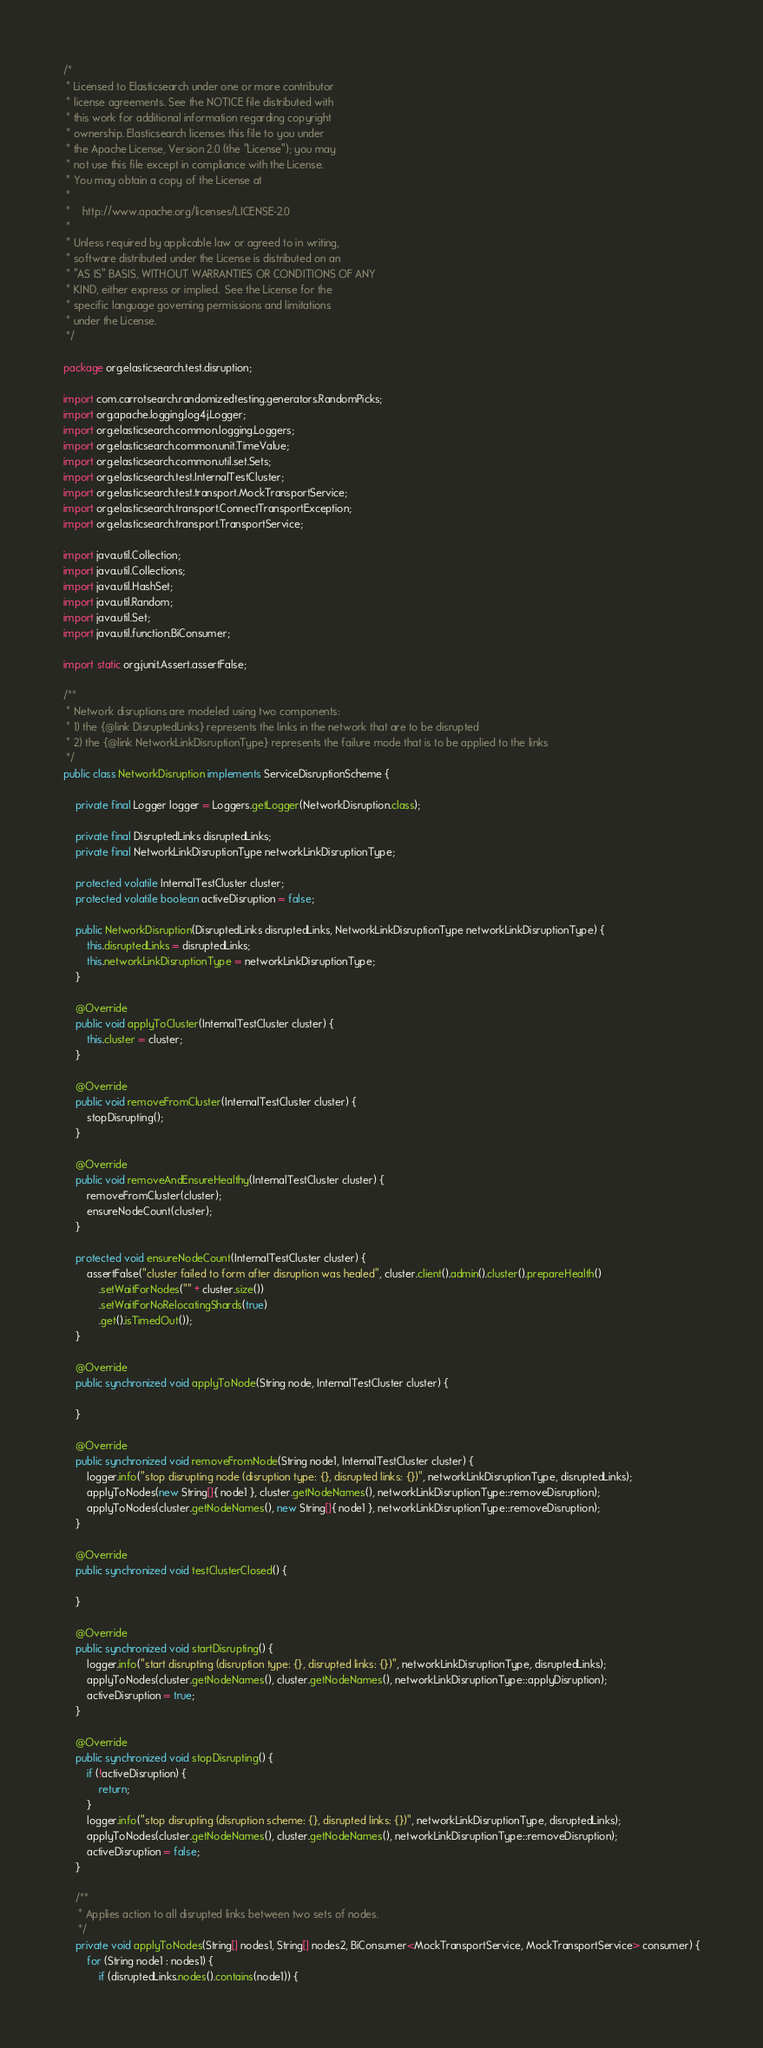<code> <loc_0><loc_0><loc_500><loc_500><_Java_>/*
 * Licensed to Elasticsearch under one or more contributor
 * license agreements. See the NOTICE file distributed with
 * this work for additional information regarding copyright
 * ownership. Elasticsearch licenses this file to you under
 * the Apache License, Version 2.0 (the "License"); you may
 * not use this file except in compliance with the License.
 * You may obtain a copy of the License at
 *
 *    http://www.apache.org/licenses/LICENSE-2.0
 *
 * Unless required by applicable law or agreed to in writing,
 * software distributed under the License is distributed on an
 * "AS IS" BASIS, WITHOUT WARRANTIES OR CONDITIONS OF ANY
 * KIND, either express or implied.  See the License for the
 * specific language governing permissions and limitations
 * under the License.
 */

package org.elasticsearch.test.disruption;

import com.carrotsearch.randomizedtesting.generators.RandomPicks;
import org.apache.logging.log4j.Logger;
import org.elasticsearch.common.logging.Loggers;
import org.elasticsearch.common.unit.TimeValue;
import org.elasticsearch.common.util.set.Sets;
import org.elasticsearch.test.InternalTestCluster;
import org.elasticsearch.test.transport.MockTransportService;
import org.elasticsearch.transport.ConnectTransportException;
import org.elasticsearch.transport.TransportService;

import java.util.Collection;
import java.util.Collections;
import java.util.HashSet;
import java.util.Random;
import java.util.Set;
import java.util.function.BiConsumer;

import static org.junit.Assert.assertFalse;

/**
 * Network disruptions are modeled using two components:
 * 1) the {@link DisruptedLinks} represents the links in the network that are to be disrupted
 * 2) the {@link NetworkLinkDisruptionType} represents the failure mode that is to be applied to the links
 */
public class NetworkDisruption implements ServiceDisruptionScheme {

    private final Logger logger = Loggers.getLogger(NetworkDisruption.class);

    private final DisruptedLinks disruptedLinks;
    private final NetworkLinkDisruptionType networkLinkDisruptionType;

    protected volatile InternalTestCluster cluster;
    protected volatile boolean activeDisruption = false;

    public NetworkDisruption(DisruptedLinks disruptedLinks, NetworkLinkDisruptionType networkLinkDisruptionType) {
        this.disruptedLinks = disruptedLinks;
        this.networkLinkDisruptionType = networkLinkDisruptionType;
    }

    @Override
    public void applyToCluster(InternalTestCluster cluster) {
        this.cluster = cluster;
    }

    @Override
    public void removeFromCluster(InternalTestCluster cluster) {
        stopDisrupting();
    }

    @Override
    public void removeAndEnsureHealthy(InternalTestCluster cluster) {
        removeFromCluster(cluster);
        ensureNodeCount(cluster);
    }

    protected void ensureNodeCount(InternalTestCluster cluster) {
        assertFalse("cluster failed to form after disruption was healed", cluster.client().admin().cluster().prepareHealth()
            .setWaitForNodes("" + cluster.size())
            .setWaitForNoRelocatingShards(true)
            .get().isTimedOut());
    }

    @Override
    public synchronized void applyToNode(String node, InternalTestCluster cluster) {

    }

    @Override
    public synchronized void removeFromNode(String node1, InternalTestCluster cluster) {
        logger.info("stop disrupting node (disruption type: {}, disrupted links: {})", networkLinkDisruptionType, disruptedLinks);
        applyToNodes(new String[]{ node1 }, cluster.getNodeNames(), networkLinkDisruptionType::removeDisruption);
        applyToNodes(cluster.getNodeNames(), new String[]{ node1 }, networkLinkDisruptionType::removeDisruption);
    }

    @Override
    public synchronized void testClusterClosed() {

    }

    @Override
    public synchronized void startDisrupting() {
        logger.info("start disrupting (disruption type: {}, disrupted links: {})", networkLinkDisruptionType, disruptedLinks);
        applyToNodes(cluster.getNodeNames(), cluster.getNodeNames(), networkLinkDisruptionType::applyDisruption);
        activeDisruption = true;
    }

    @Override
    public synchronized void stopDisrupting() {
        if (!activeDisruption) {
            return;
        }
        logger.info("stop disrupting (disruption scheme: {}, disrupted links: {})", networkLinkDisruptionType, disruptedLinks);
        applyToNodes(cluster.getNodeNames(), cluster.getNodeNames(), networkLinkDisruptionType::removeDisruption);
        activeDisruption = false;
    }

    /**
     * Applies action to all disrupted links between two sets of nodes.
     */
    private void applyToNodes(String[] nodes1, String[] nodes2, BiConsumer<MockTransportService, MockTransportService> consumer) {
        for (String node1 : nodes1) {
            if (disruptedLinks.nodes().contains(node1)) {</code> 